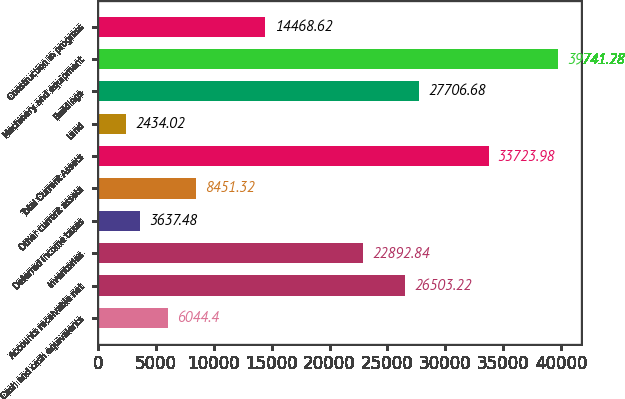Convert chart. <chart><loc_0><loc_0><loc_500><loc_500><bar_chart><fcel>Cash and cash equivalents<fcel>Accounts receivable net<fcel>Inventories<fcel>Deferred income taxes<fcel>Other current assets<fcel>Total Current Assets<fcel>Land<fcel>Buildings<fcel>Machinery and equipment<fcel>Construction in progress<nl><fcel>6044.4<fcel>26503.2<fcel>22892.8<fcel>3637.48<fcel>8451.32<fcel>33724<fcel>2434.02<fcel>27706.7<fcel>39741.3<fcel>14468.6<nl></chart> 